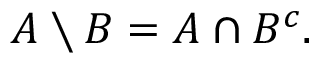<formula> <loc_0><loc_0><loc_500><loc_500>A \ B = A \cap B ^ { c } .</formula> 